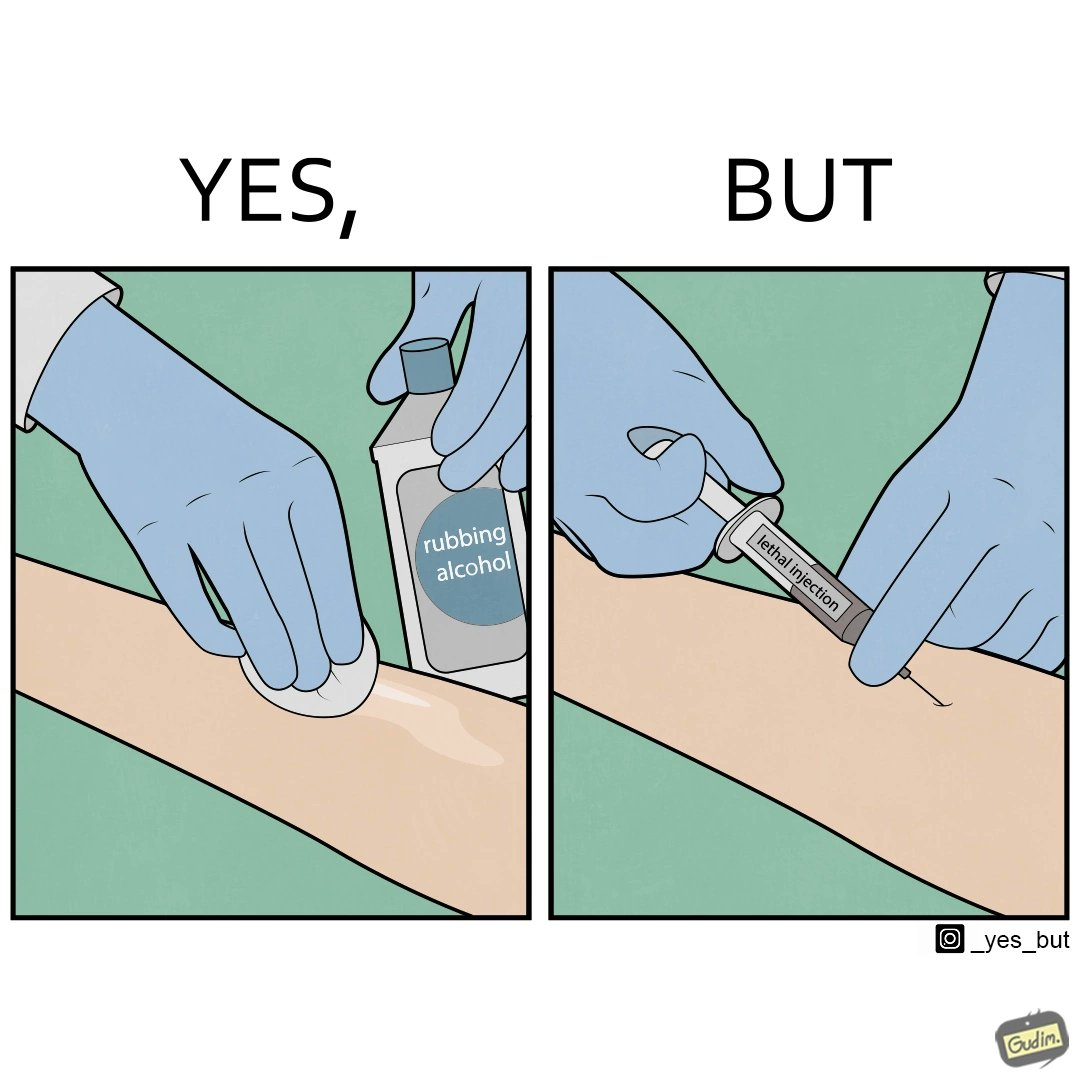Describe the content of this image. The image is ironical, as rubbing alcohol is used to clean a place on the arm for giving an injection, while the injection itself is 'lethal'. 